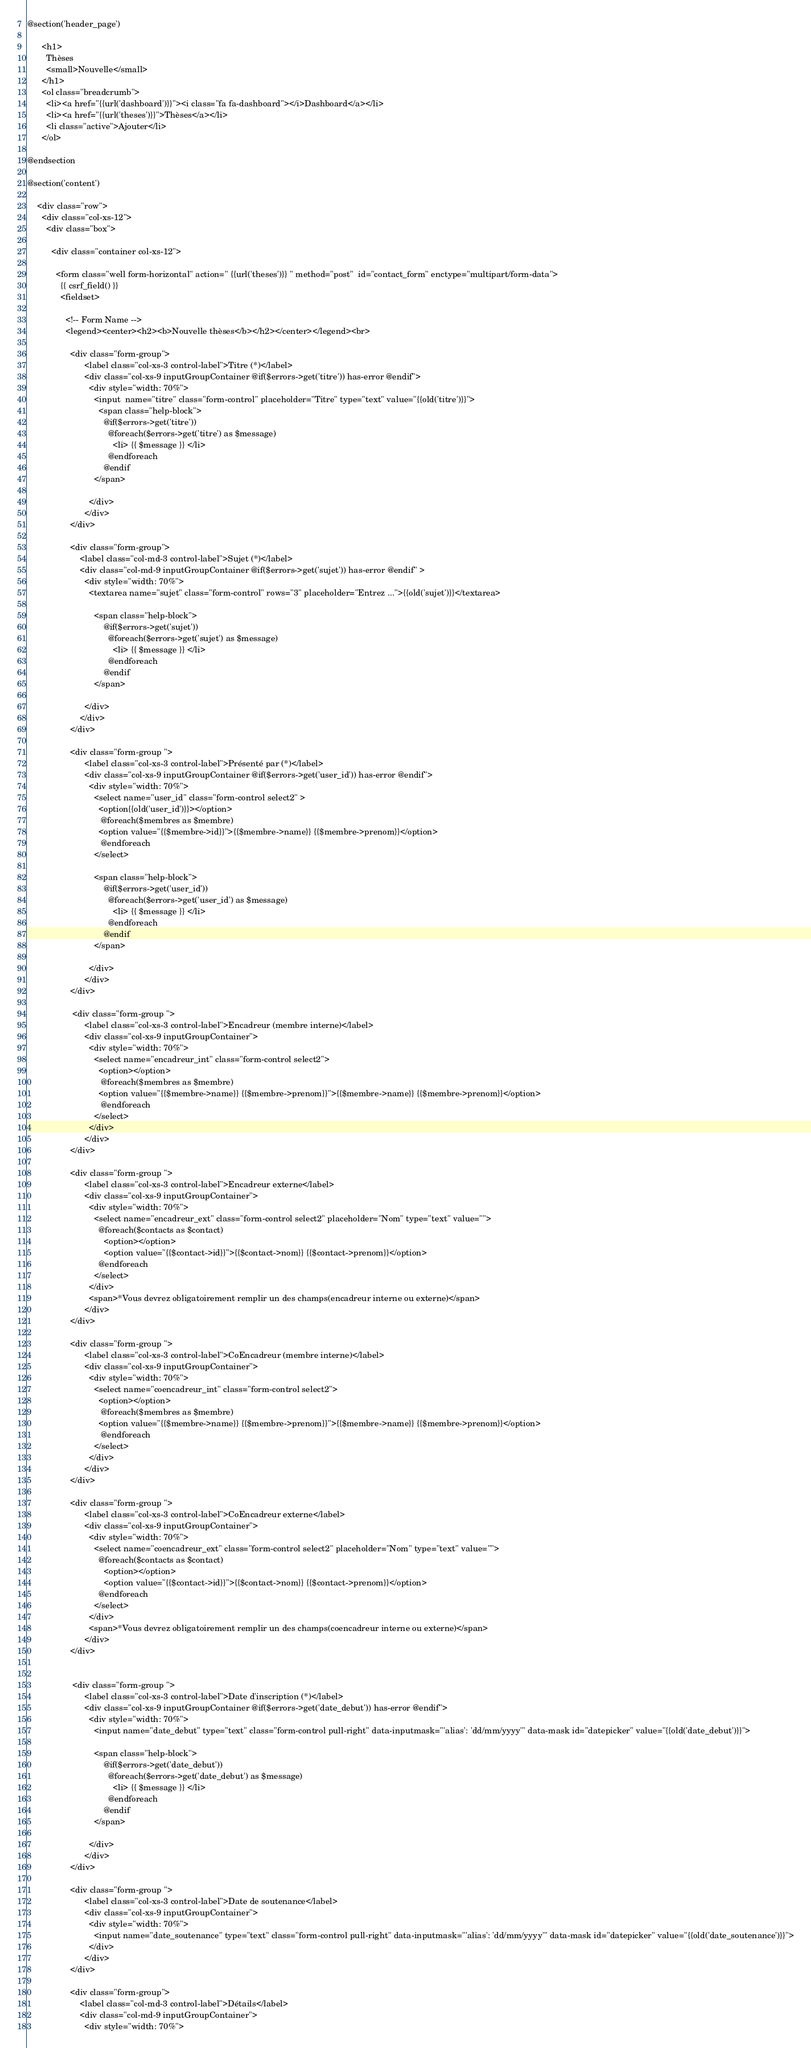Convert code to text. <code><loc_0><loc_0><loc_500><loc_500><_PHP_>
@section('header_page')

      <h1>
        Thèses
        <small>Nouvelle</small>
      </h1>
      <ol class="breadcrumb">
        <li><a href="{{url('dashboard')}}"><i class="fa fa-dashboard"></i>Dashboard</a></li>
        <li><a href="{{url('theses')}}">Thèses</a></li>
        <li class="active">Ajouter</li>
      </ol>

@endsection

@section('content')

    <div class="row">
      <div class="col-xs-12">
        <div class="box">
            
          <div class="container col-xs-12">

            <form class="well form-horizontal" action=" {{url('theses')}} " method="post"  id="contact_form" enctype="multipart/form-data">
              {{ csrf_field() }}
              <fieldset>

                <!-- Form Name -->
                <legend><center><h2><b>Nouvelle thèses</b></h2></center></legend><br>

                  <div class="form-group">
                        <label class="col-xs-3 control-label">Titre (*)</label>  
                        <div class="col-xs-9 inputGroupContainer @if($errors->get('titre')) has-error @endif">
                          <div style="width: 70%">
                            <input  name="titre" class="form-control" placeholder="Titre" type="text" value="{{old('titre')}}">
                              <span class="help-block">
                                @if($errors->get('titre'))
                                  @foreach($errors->get('titre') as $message)
                                    <li> {{ $message }} </li>
                                  @endforeach
                                @endif
                            </span>
                              
                          </div>
                        </div>
                  </div>  

                  <div class="form-group">
                      <label class="col-md-3 control-label">Sujet (*)</label>
                      <div class="col-md-9 inputGroupContainer @if($errors->get('sujet')) has-error @endif" >
                        <div style="width: 70%">
                          <textarea name="sujet" class="form-control" rows="3" placeholder="Entrez ...">{{old('sujet')}}</textarea>

                            <span class="help-block">
                                @if($errors->get('sujet'))
                                  @foreach($errors->get('sujet') as $message)
                                    <li> {{ $message }} </li>
                                  @endforeach
                                @endif
                            </span>

                        </div>
                      </div>
                  </div>

                  <div class="form-group ">
                        <label class="col-xs-3 control-label">Présenté par (*)</label>  
                        <div class="col-xs-9 inputGroupContainer @if($errors->get('user_id')) has-error @endif">
                          <div style="width: 70%">
                            <select name="user_id" class="form-control select2" >
                              <option{{old('user_id')}}></option>
                               @foreach($membres as $membre)
                              <option value="{{$membre->id}}">{{$membre->name}} {{$membre->prenom}}</option>
                               @endforeach
                            </select>

                            <span class="help-block">
                                @if($errors->get('user_id'))
                                  @foreach($errors->get('user_id') as $message)
                                    <li> {{ $message }} </li>
                                  @endforeach
                                @endif
                            </span>

                          </div>
                        </div>
                  </div>  

                   <div class="form-group ">
                        <label class="col-xs-3 control-label">Encadreur (membre interne)</label>  
                        <div class="col-xs-9 inputGroupContainer">
                          <div style="width: 70%">
                            <select name="encadreur_int" class="form-control select2">
                              <option></option>
                               @foreach($membres as $membre)
                              <option value="{{$membre->name}} {{$membre->prenom}}">{{$membre->name}} {{$membre->prenom}}</option>
                               @endforeach
                            </select>
                          </div>
                        </div>
                  </div> 

                  <div class="form-group ">
                        <label class="col-xs-3 control-label">Encadreur externe</label>  
                        <div class="col-xs-9 inputGroupContainer">
                          <div style="width: 70%">
                            <select name="encadreur_ext" class="form-control select2" placeholder="Nom" type="text" value="">
                              @foreach($contacts as $contact)
                                <option></option>
                                <option value="{{$contact->id}}">{{$contact->nom}} {{$contact->prenom}}</option>
                              @endforeach
                            </select>
                          </div>
                          <span>*Vous devrez obligatoirement remplir un des champs(encadreur interne ou externe)</span>
                        </div>
                  </div> 

                  <div class="form-group ">
                        <label class="col-xs-3 control-label">CoEncadreur (membre interne)</label>  
                        <div class="col-xs-9 inputGroupContainer">
                          <div style="width: 70%">
                            <select name="coencadreur_int" class="form-control select2">
                              <option></option>
                               @foreach($membres as $membre)
                              <option value="{{$membre->name}} {{$membre->prenom}}">{{$membre->name}} {{$membre->prenom}}</option>
                               @endforeach
                            </select>
                          </div>
                        </div>
                  </div> 

                  <div class="form-group ">
                        <label class="col-xs-3 control-label">CoEncadreur externe</label>  
                        <div class="col-xs-9 inputGroupContainer">
                          <div style="width: 70%">
                            <select name="coencadreur_ext" class="form-control select2" placeholder="Nom" type="text" value="">
                              @foreach($contacts as $contact)
                                <option></option>
                                <option value="{{$contact->id}}">{{$contact->nom}} {{$contact->prenom}}</option>
                              @endforeach
                            </select>
                          </div>
                          <span>*Vous devrez obligatoirement remplir un des champs(coencadreur interne ou externe)</span>
                        </div>
                  </div> 
                

                   <div class="form-group ">
                        <label class="col-xs-3 control-label">Date d'inscription (*)</label>  
                        <div class="col-xs-9 inputGroupContainer @if($errors->get('date_debut')) has-error @endif">
                          <div style="width: 70%">
                            <input name="date_debut" type="text" class="form-control pull-right" data-inputmask="'alias': 'dd/mm/yyyy'" data-mask id="datepicker" value="{{old('date_debut')}}">

                            <span class="help-block">
                                @if($errors->get('date_debut'))
                                  @foreach($errors->get('date_debut') as $message)
                                    <li> {{ $message }} </li>
                                  @endforeach
                                @endif
                            </span>

                          </div>
                        </div>
                  </div>

                  <div class="form-group ">
                        <label class="col-xs-3 control-label">Date de soutenance</label>  
                        <div class="col-xs-9 inputGroupContainer">
                          <div style="width: 70%">
                            <input name="date_soutenance" type="text" class="form-control pull-right" data-inputmask="'alias': 'dd/mm/yyyy'" data-mask id="datepicker" value="{{old('date_soutenance')}}">
                          </div>
                        </div>
                  </div>

                  <div class="form-group">
                      <label class="col-md-3 control-label">Détails</label>
                      <div class="col-md-9 inputGroupContainer">
                        <div style="width: 70%"></code> 